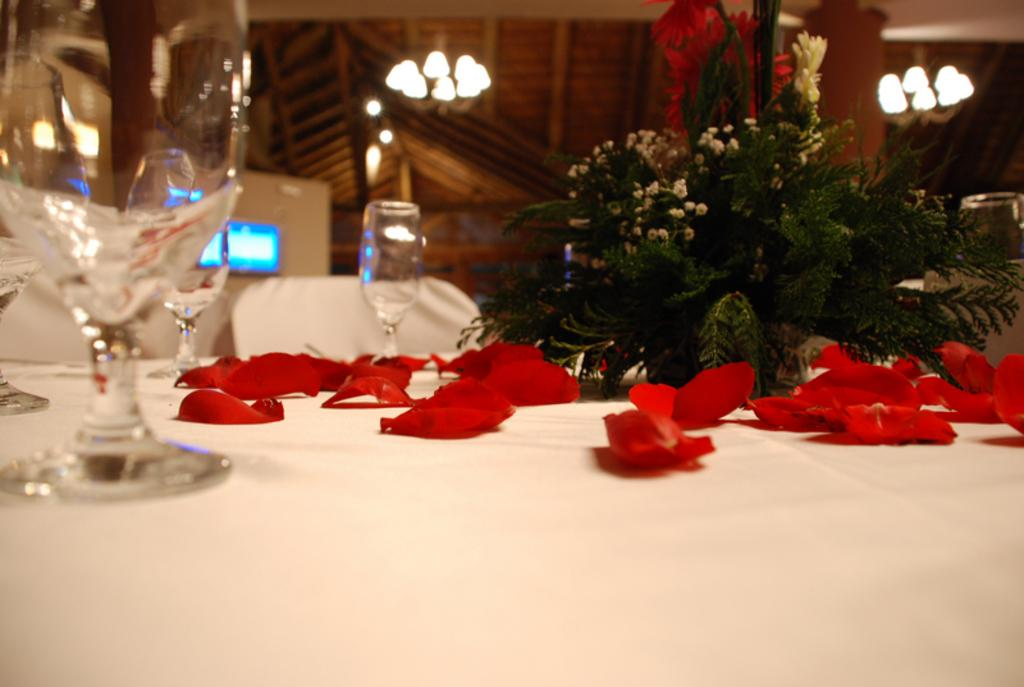What type of petals can be seen in the image? There are rose petals in the image. What objects are on the white table? There are wine glasses on a white table. What is included in the bouquet in the image? The information provided does not specify the contents of the bouquet. What type of lighting is present in the image? There are lights at the top of the image. What is visible at the back of the image? There are screens at the back of the image. What type of lettuce is used to decorate the wine glasses in the image? There is no lettuce present in the image; it features rose petals, wine glasses, a bouquet, lights, and screens. 